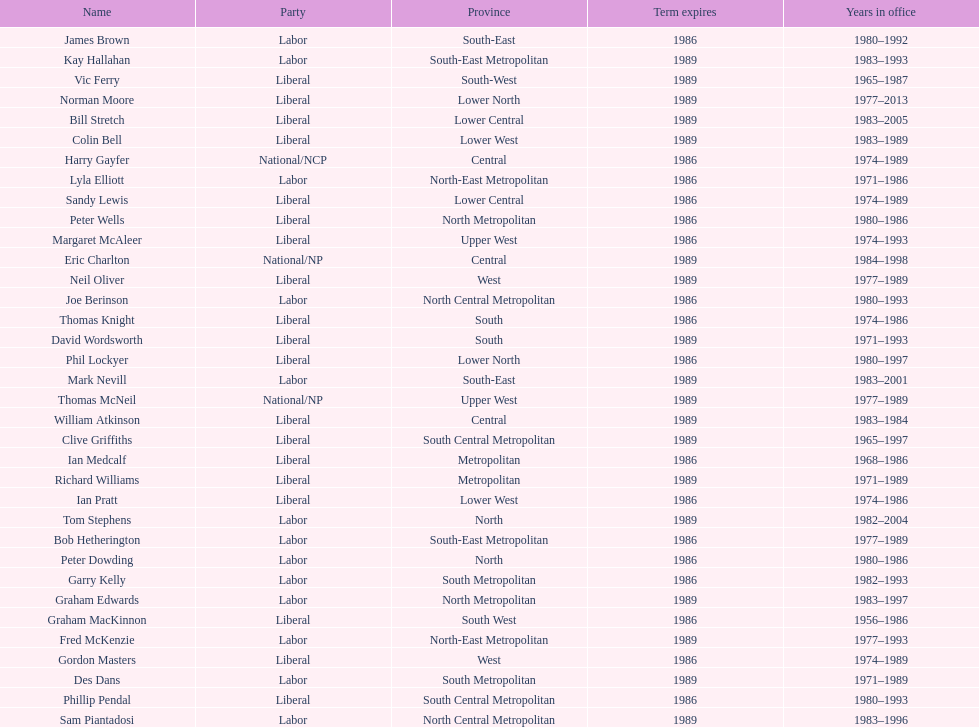Which party has the most membership? Liberal. 